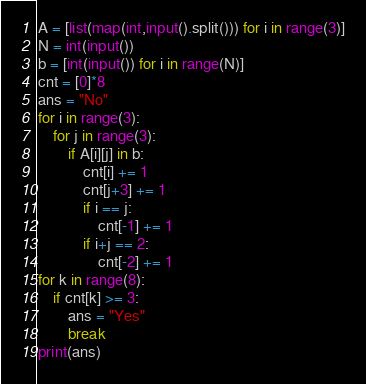Convert code to text. <code><loc_0><loc_0><loc_500><loc_500><_Python_>A = [list(map(int,input().split())) for i in range(3)]
N = int(input())
b = [int(input()) for i in range(N)]
cnt = [0]*8
ans = "No"
for i in range(3):
    for j in range(3):
        if A[i][j] in b:
            cnt[i] += 1
            cnt[j+3] += 1
            if i == j:
                cnt[-1] += 1
            if i+j == 2:
                cnt[-2] += 1
for k in range(8):
    if cnt[k] >= 3:
        ans = "Yes"
        break
print(ans)</code> 